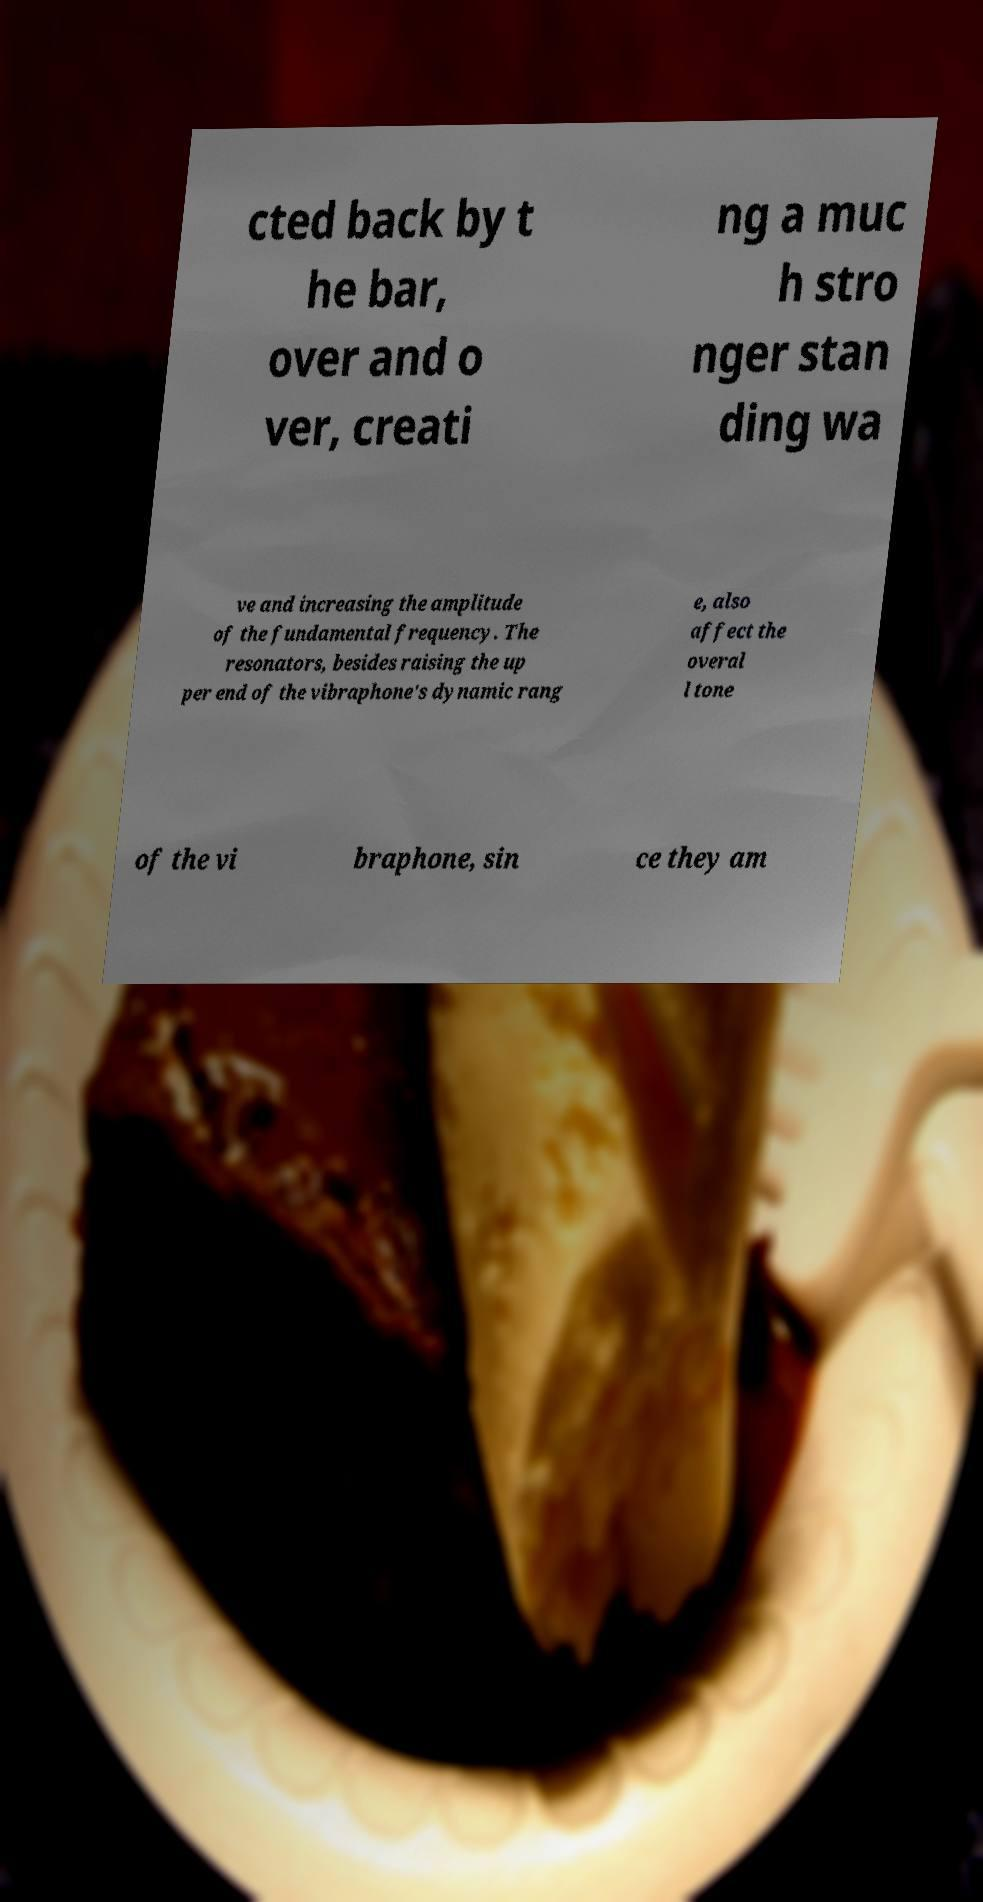Please read and relay the text visible in this image. What does it say? cted back by t he bar, over and o ver, creati ng a muc h stro nger stan ding wa ve and increasing the amplitude of the fundamental frequency. The resonators, besides raising the up per end of the vibraphone's dynamic rang e, also affect the overal l tone of the vi braphone, sin ce they am 